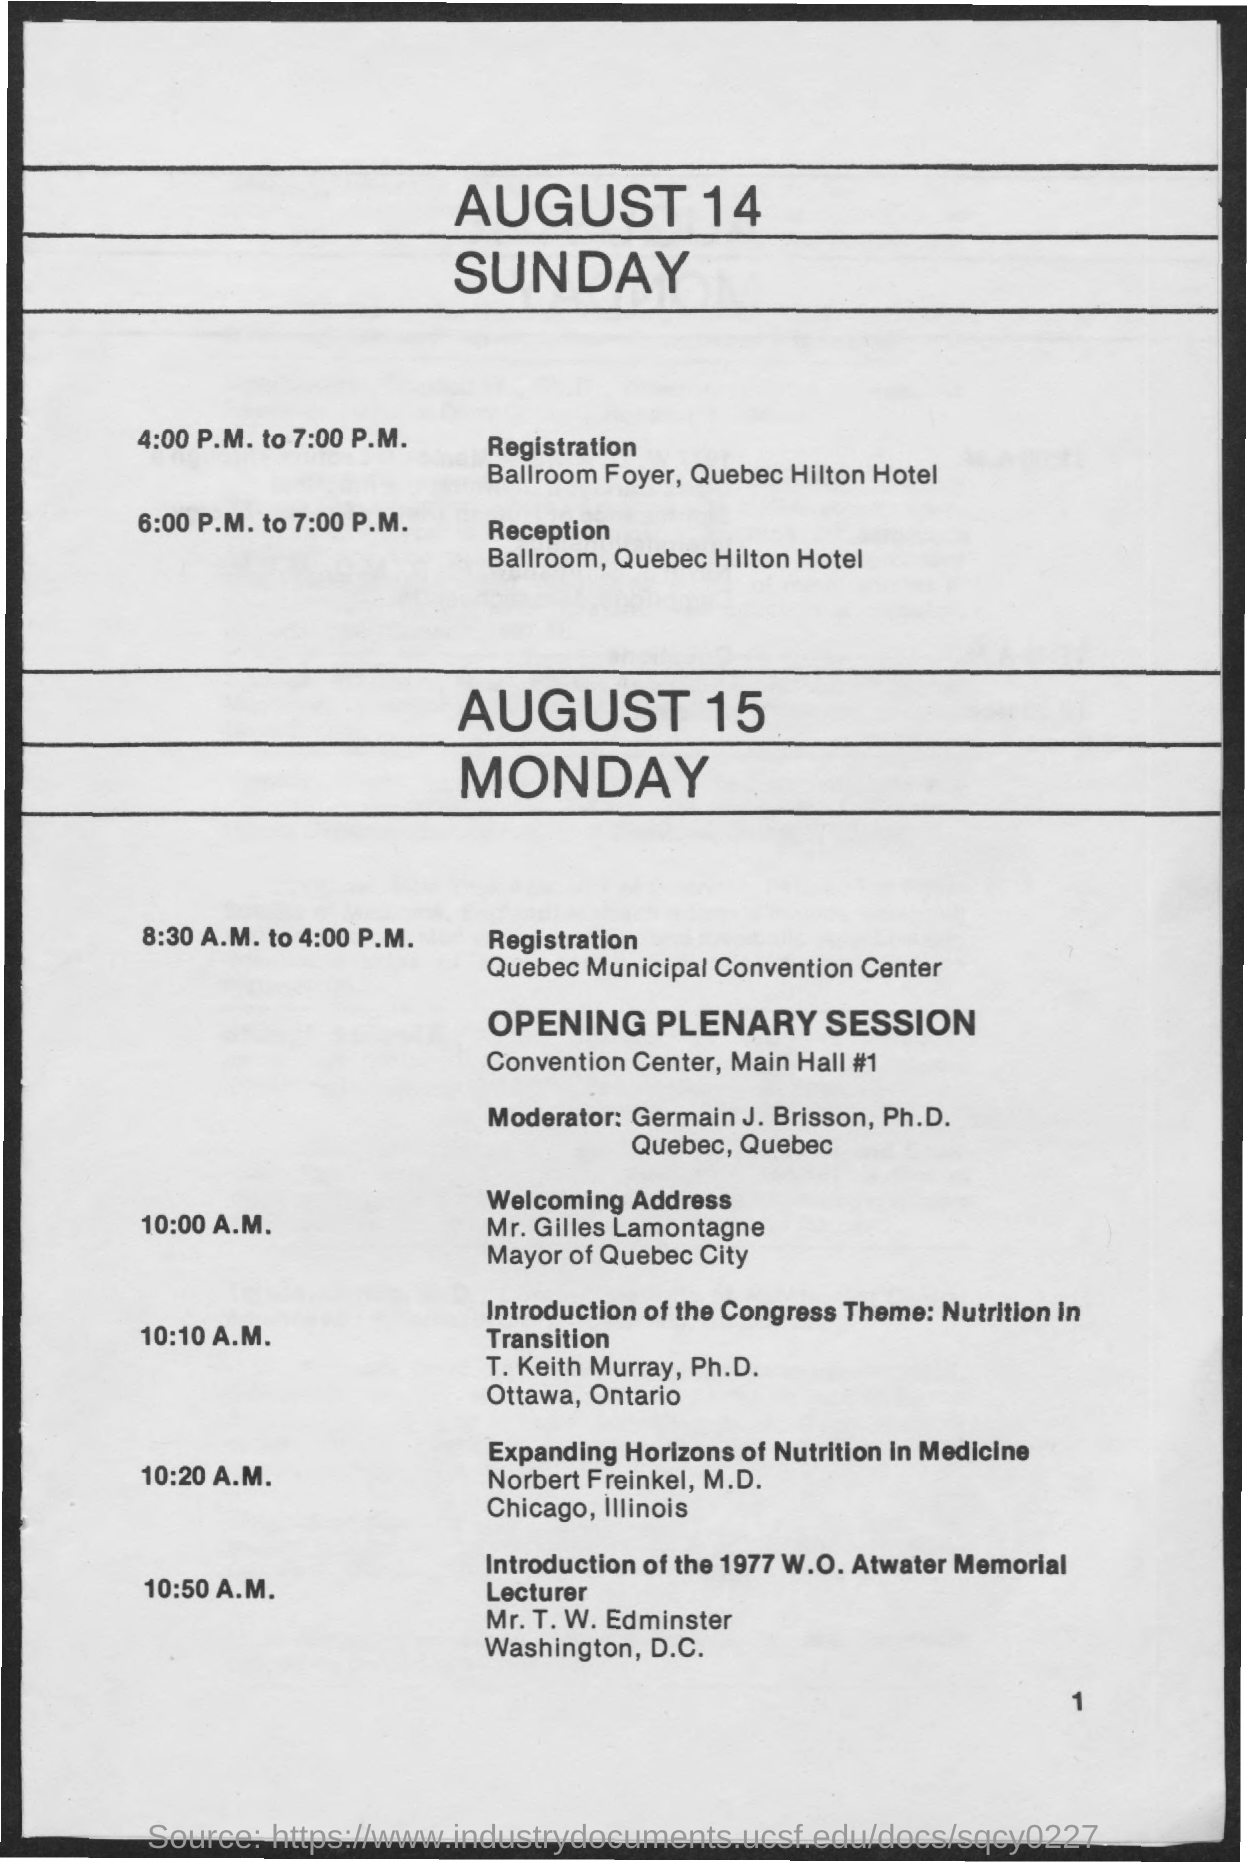Draw attention to some important aspects in this diagram. Timings for registration are scheduled from 4:00 PM to 7:00 PM on Sunday, August 14. Quebec City's current mayor is Gilles Lamontagne. The venue for the Reception on August 14, Sunday, is the Ballroom at the Quebec Hilton Hotel. On August 14, Sunday, the timings for Reception are scheduled from 6:00 P.M. to 7:00 P.M. On August 14, Sunday, the venue for registration is the Ballroom Foyer of the Quebec Hilton Hotel. 